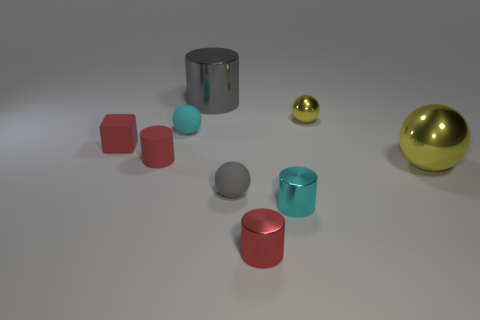Subtract all small red metallic cylinders. How many cylinders are left? 3 Subtract 1 spheres. How many spheres are left? 3 Add 1 tiny yellow metal things. How many objects exist? 10 Subtract all brown cylinders. Subtract all brown blocks. How many cylinders are left? 4 Subtract all cylinders. How many objects are left? 5 Add 9 tiny red metal cylinders. How many tiny red metal cylinders exist? 10 Subtract 0 purple cylinders. How many objects are left? 9 Subtract all blue metal objects. Subtract all tiny cylinders. How many objects are left? 6 Add 8 red rubber cylinders. How many red rubber cylinders are left? 9 